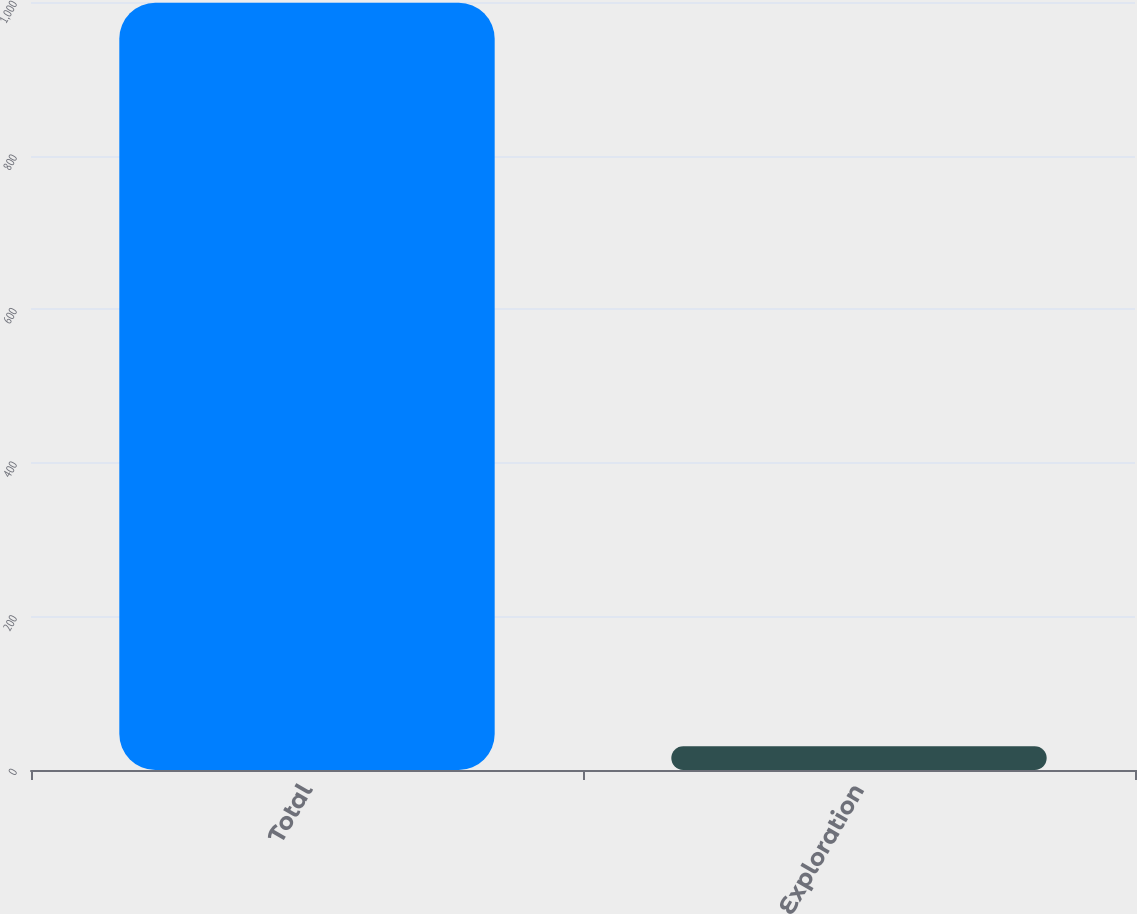Convert chart to OTSL. <chart><loc_0><loc_0><loc_500><loc_500><bar_chart><fcel>Total<fcel>Exploration<nl><fcel>999<fcel>31<nl></chart> 